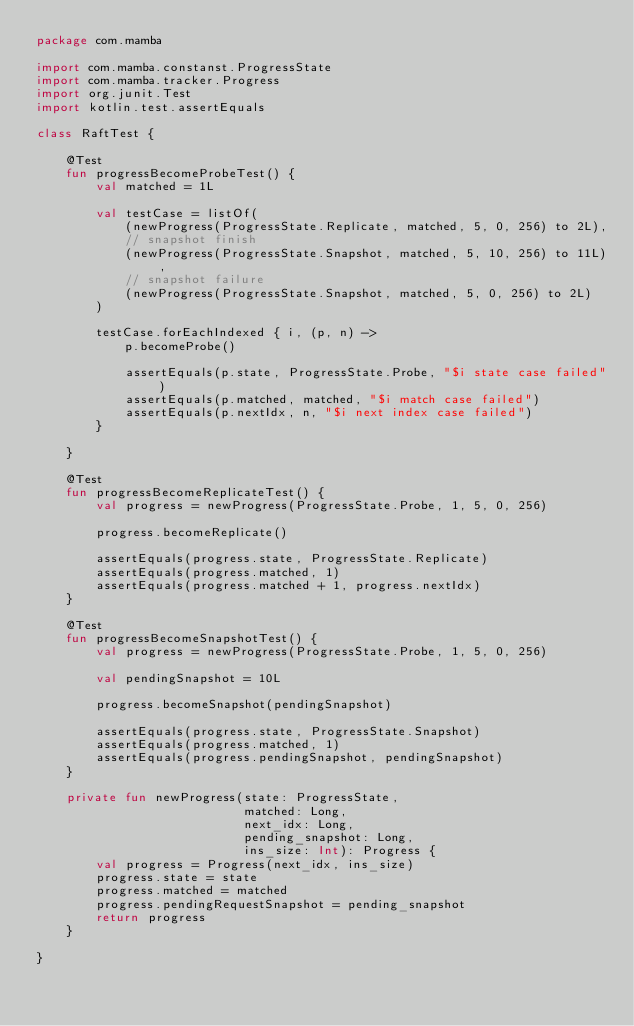Convert code to text. <code><loc_0><loc_0><loc_500><loc_500><_Kotlin_>package com.mamba

import com.mamba.constanst.ProgressState
import com.mamba.tracker.Progress
import org.junit.Test
import kotlin.test.assertEquals

class RaftTest {

    @Test
    fun progressBecomeProbeTest() {
        val matched = 1L

        val testCase = listOf(
            (newProgress(ProgressState.Replicate, matched, 5, 0, 256) to 2L),
            // snapshot finish
            (newProgress(ProgressState.Snapshot, matched, 5, 10, 256) to 11L),
            // snapshot failure
            (newProgress(ProgressState.Snapshot, matched, 5, 0, 256) to 2L)
        )

        testCase.forEachIndexed { i, (p, n) ->
            p.becomeProbe()

            assertEquals(p.state, ProgressState.Probe, "$i state case failed")
            assertEquals(p.matched, matched, "$i match case failed")
            assertEquals(p.nextIdx, n, "$i next index case failed")
        }

    }

    @Test
    fun progressBecomeReplicateTest() {
        val progress = newProgress(ProgressState.Probe, 1, 5, 0, 256)

        progress.becomeReplicate()

        assertEquals(progress.state, ProgressState.Replicate)
        assertEquals(progress.matched, 1)
        assertEquals(progress.matched + 1, progress.nextIdx)
    }

    @Test
    fun progressBecomeSnapshotTest() {
        val progress = newProgress(ProgressState.Probe, 1, 5, 0, 256)

        val pendingSnapshot = 10L

        progress.becomeSnapshot(pendingSnapshot)

        assertEquals(progress.state, ProgressState.Snapshot)
        assertEquals(progress.matched, 1)
        assertEquals(progress.pendingSnapshot, pendingSnapshot)
    }

    private fun newProgress(state: ProgressState,
                            matched: Long,
                            next_idx: Long,
                            pending_snapshot: Long,
                            ins_size: Int): Progress {
        val progress = Progress(next_idx, ins_size)
        progress.state = state
        progress.matched = matched
        progress.pendingRequestSnapshot = pending_snapshot
        return progress
    }

}</code> 